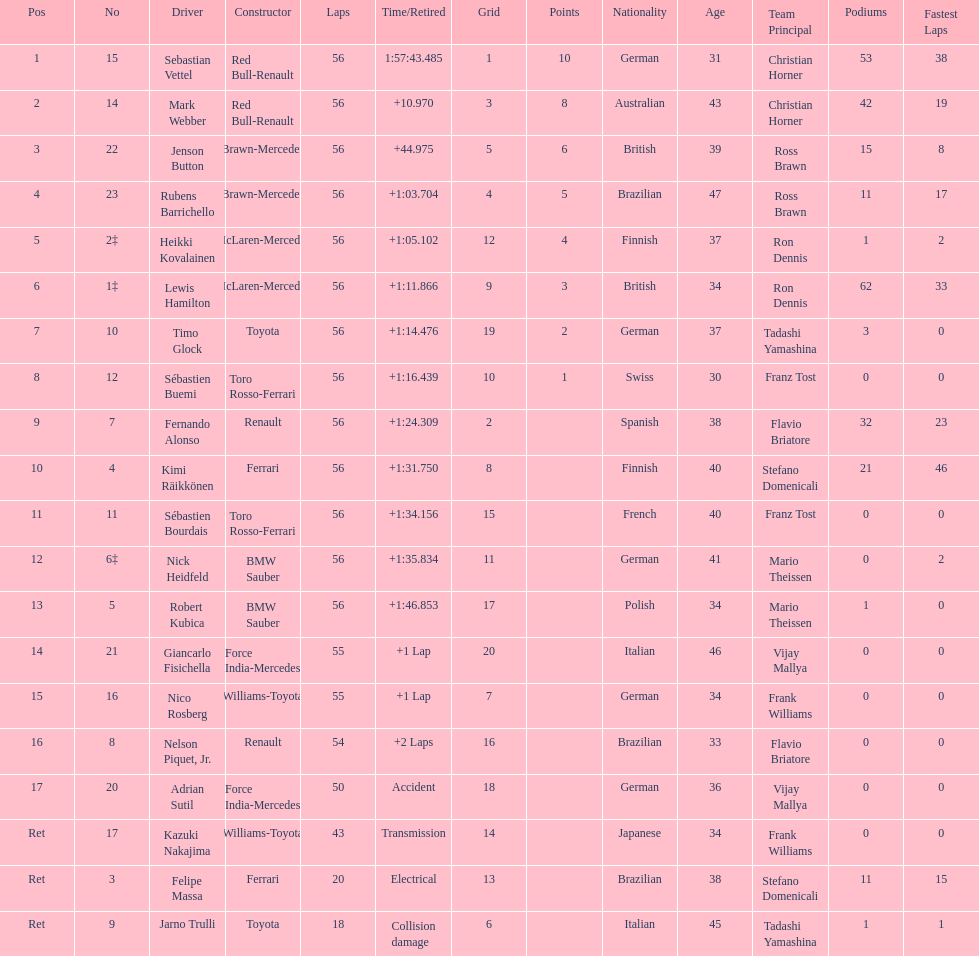What is the name of a driver that ferrari was not a constructor for? Sebastian Vettel. 